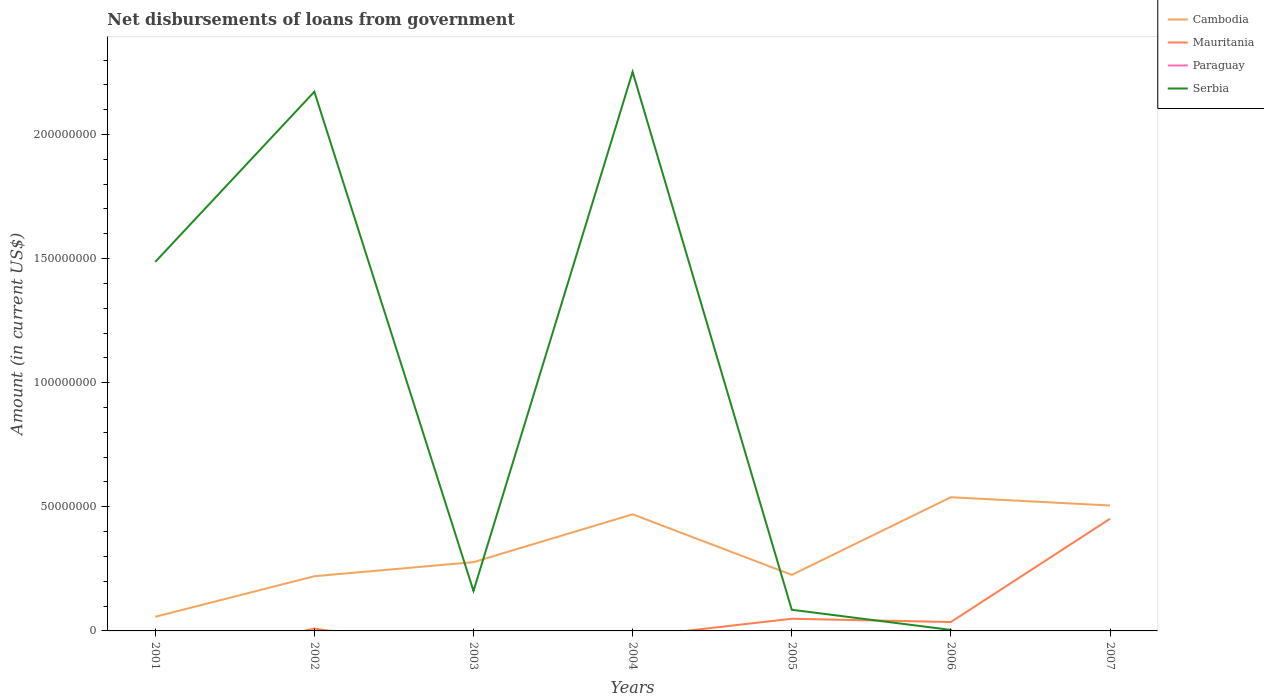Does the line corresponding to Mauritania intersect with the line corresponding to Serbia?
Your answer should be compact. Yes. Across all years, what is the maximum amount of loan disbursed from government in Serbia?
Keep it short and to the point. 0. What is the total amount of loan disbursed from government in Cambodia in the graph?
Make the answer very short. -5.67e+06. What is the difference between the highest and the second highest amount of loan disbursed from government in Cambodia?
Your answer should be very brief. 4.82e+07. How many lines are there?
Ensure brevity in your answer.  3. Are the values on the major ticks of Y-axis written in scientific E-notation?
Offer a very short reply. No. What is the title of the graph?
Provide a succinct answer. Net disbursements of loans from government. What is the label or title of the X-axis?
Offer a very short reply. Years. What is the Amount (in current US$) in Cambodia in 2001?
Your answer should be very brief. 5.69e+06. What is the Amount (in current US$) in Paraguay in 2001?
Provide a succinct answer. 0. What is the Amount (in current US$) in Serbia in 2001?
Your response must be concise. 1.49e+08. What is the Amount (in current US$) in Cambodia in 2002?
Your response must be concise. 2.20e+07. What is the Amount (in current US$) in Mauritania in 2002?
Your response must be concise. 9.69e+05. What is the Amount (in current US$) in Serbia in 2002?
Offer a terse response. 2.17e+08. What is the Amount (in current US$) in Cambodia in 2003?
Your response must be concise. 2.77e+07. What is the Amount (in current US$) of Paraguay in 2003?
Offer a very short reply. 0. What is the Amount (in current US$) of Serbia in 2003?
Offer a terse response. 1.61e+07. What is the Amount (in current US$) of Cambodia in 2004?
Keep it short and to the point. 4.70e+07. What is the Amount (in current US$) of Mauritania in 2004?
Offer a terse response. 0. What is the Amount (in current US$) in Serbia in 2004?
Offer a terse response. 2.25e+08. What is the Amount (in current US$) in Cambodia in 2005?
Your answer should be very brief. 2.26e+07. What is the Amount (in current US$) of Mauritania in 2005?
Give a very brief answer. 4.90e+06. What is the Amount (in current US$) of Serbia in 2005?
Provide a short and direct response. 8.52e+06. What is the Amount (in current US$) in Cambodia in 2006?
Offer a very short reply. 5.39e+07. What is the Amount (in current US$) of Mauritania in 2006?
Ensure brevity in your answer.  3.58e+06. What is the Amount (in current US$) of Cambodia in 2007?
Provide a short and direct response. 5.05e+07. What is the Amount (in current US$) of Mauritania in 2007?
Keep it short and to the point. 4.52e+07. What is the Amount (in current US$) in Serbia in 2007?
Your answer should be very brief. 0. Across all years, what is the maximum Amount (in current US$) of Cambodia?
Ensure brevity in your answer.  5.39e+07. Across all years, what is the maximum Amount (in current US$) in Mauritania?
Offer a terse response. 4.52e+07. Across all years, what is the maximum Amount (in current US$) in Serbia?
Ensure brevity in your answer.  2.25e+08. Across all years, what is the minimum Amount (in current US$) of Cambodia?
Provide a succinct answer. 5.69e+06. Across all years, what is the minimum Amount (in current US$) of Serbia?
Your response must be concise. 0. What is the total Amount (in current US$) in Cambodia in the graph?
Ensure brevity in your answer.  2.29e+08. What is the total Amount (in current US$) in Mauritania in the graph?
Keep it short and to the point. 5.46e+07. What is the total Amount (in current US$) in Serbia in the graph?
Your answer should be very brief. 6.16e+08. What is the difference between the Amount (in current US$) of Cambodia in 2001 and that in 2002?
Your answer should be compact. -1.63e+07. What is the difference between the Amount (in current US$) in Serbia in 2001 and that in 2002?
Ensure brevity in your answer.  -6.86e+07. What is the difference between the Amount (in current US$) of Cambodia in 2001 and that in 2003?
Give a very brief answer. -2.20e+07. What is the difference between the Amount (in current US$) in Serbia in 2001 and that in 2003?
Give a very brief answer. 1.33e+08. What is the difference between the Amount (in current US$) of Cambodia in 2001 and that in 2004?
Provide a succinct answer. -4.13e+07. What is the difference between the Amount (in current US$) in Serbia in 2001 and that in 2004?
Give a very brief answer. -7.66e+07. What is the difference between the Amount (in current US$) in Cambodia in 2001 and that in 2005?
Keep it short and to the point. -1.69e+07. What is the difference between the Amount (in current US$) of Serbia in 2001 and that in 2005?
Keep it short and to the point. 1.40e+08. What is the difference between the Amount (in current US$) of Cambodia in 2001 and that in 2006?
Ensure brevity in your answer.  -4.82e+07. What is the difference between the Amount (in current US$) of Serbia in 2001 and that in 2006?
Provide a short and direct response. 1.48e+08. What is the difference between the Amount (in current US$) in Cambodia in 2001 and that in 2007?
Keep it short and to the point. -4.48e+07. What is the difference between the Amount (in current US$) in Cambodia in 2002 and that in 2003?
Provide a short and direct response. -5.67e+06. What is the difference between the Amount (in current US$) in Serbia in 2002 and that in 2003?
Give a very brief answer. 2.01e+08. What is the difference between the Amount (in current US$) in Cambodia in 2002 and that in 2004?
Your response must be concise. -2.49e+07. What is the difference between the Amount (in current US$) in Serbia in 2002 and that in 2004?
Provide a succinct answer. -7.99e+06. What is the difference between the Amount (in current US$) of Cambodia in 2002 and that in 2005?
Your answer should be compact. -5.41e+05. What is the difference between the Amount (in current US$) in Mauritania in 2002 and that in 2005?
Keep it short and to the point. -3.93e+06. What is the difference between the Amount (in current US$) of Serbia in 2002 and that in 2005?
Your answer should be very brief. 2.09e+08. What is the difference between the Amount (in current US$) of Cambodia in 2002 and that in 2006?
Offer a terse response. -3.18e+07. What is the difference between the Amount (in current US$) in Mauritania in 2002 and that in 2006?
Offer a very short reply. -2.61e+06. What is the difference between the Amount (in current US$) of Serbia in 2002 and that in 2006?
Offer a terse response. 2.17e+08. What is the difference between the Amount (in current US$) in Cambodia in 2002 and that in 2007?
Make the answer very short. -2.85e+07. What is the difference between the Amount (in current US$) of Mauritania in 2002 and that in 2007?
Give a very brief answer. -4.42e+07. What is the difference between the Amount (in current US$) of Cambodia in 2003 and that in 2004?
Provide a short and direct response. -1.93e+07. What is the difference between the Amount (in current US$) of Serbia in 2003 and that in 2004?
Your response must be concise. -2.09e+08. What is the difference between the Amount (in current US$) in Cambodia in 2003 and that in 2005?
Your response must be concise. 5.13e+06. What is the difference between the Amount (in current US$) of Serbia in 2003 and that in 2005?
Keep it short and to the point. 7.58e+06. What is the difference between the Amount (in current US$) of Cambodia in 2003 and that in 2006?
Give a very brief answer. -2.62e+07. What is the difference between the Amount (in current US$) in Serbia in 2003 and that in 2006?
Your answer should be compact. 1.57e+07. What is the difference between the Amount (in current US$) of Cambodia in 2003 and that in 2007?
Your answer should be very brief. -2.28e+07. What is the difference between the Amount (in current US$) in Cambodia in 2004 and that in 2005?
Ensure brevity in your answer.  2.44e+07. What is the difference between the Amount (in current US$) of Serbia in 2004 and that in 2005?
Give a very brief answer. 2.17e+08. What is the difference between the Amount (in current US$) in Cambodia in 2004 and that in 2006?
Give a very brief answer. -6.88e+06. What is the difference between the Amount (in current US$) of Serbia in 2004 and that in 2006?
Make the answer very short. 2.25e+08. What is the difference between the Amount (in current US$) in Cambodia in 2004 and that in 2007?
Provide a succinct answer. -3.54e+06. What is the difference between the Amount (in current US$) in Cambodia in 2005 and that in 2006?
Keep it short and to the point. -3.13e+07. What is the difference between the Amount (in current US$) of Mauritania in 2005 and that in 2006?
Offer a very short reply. 1.32e+06. What is the difference between the Amount (in current US$) in Serbia in 2005 and that in 2006?
Offer a very short reply. 8.12e+06. What is the difference between the Amount (in current US$) in Cambodia in 2005 and that in 2007?
Provide a succinct answer. -2.79e+07. What is the difference between the Amount (in current US$) in Mauritania in 2005 and that in 2007?
Your response must be concise. -4.03e+07. What is the difference between the Amount (in current US$) in Cambodia in 2006 and that in 2007?
Keep it short and to the point. 3.34e+06. What is the difference between the Amount (in current US$) of Mauritania in 2006 and that in 2007?
Offer a terse response. -4.16e+07. What is the difference between the Amount (in current US$) of Cambodia in 2001 and the Amount (in current US$) of Mauritania in 2002?
Offer a terse response. 4.72e+06. What is the difference between the Amount (in current US$) in Cambodia in 2001 and the Amount (in current US$) in Serbia in 2002?
Keep it short and to the point. -2.12e+08. What is the difference between the Amount (in current US$) of Cambodia in 2001 and the Amount (in current US$) of Serbia in 2003?
Your response must be concise. -1.04e+07. What is the difference between the Amount (in current US$) of Cambodia in 2001 and the Amount (in current US$) of Serbia in 2004?
Keep it short and to the point. -2.20e+08. What is the difference between the Amount (in current US$) in Cambodia in 2001 and the Amount (in current US$) in Mauritania in 2005?
Ensure brevity in your answer.  7.90e+05. What is the difference between the Amount (in current US$) in Cambodia in 2001 and the Amount (in current US$) in Serbia in 2005?
Give a very brief answer. -2.84e+06. What is the difference between the Amount (in current US$) of Cambodia in 2001 and the Amount (in current US$) of Mauritania in 2006?
Give a very brief answer. 2.11e+06. What is the difference between the Amount (in current US$) of Cambodia in 2001 and the Amount (in current US$) of Serbia in 2006?
Your answer should be compact. 5.29e+06. What is the difference between the Amount (in current US$) of Cambodia in 2001 and the Amount (in current US$) of Mauritania in 2007?
Give a very brief answer. -3.95e+07. What is the difference between the Amount (in current US$) in Cambodia in 2002 and the Amount (in current US$) in Serbia in 2003?
Keep it short and to the point. 5.93e+06. What is the difference between the Amount (in current US$) of Mauritania in 2002 and the Amount (in current US$) of Serbia in 2003?
Make the answer very short. -1.51e+07. What is the difference between the Amount (in current US$) of Cambodia in 2002 and the Amount (in current US$) of Serbia in 2004?
Your answer should be very brief. -2.03e+08. What is the difference between the Amount (in current US$) in Mauritania in 2002 and the Amount (in current US$) in Serbia in 2004?
Your answer should be compact. -2.24e+08. What is the difference between the Amount (in current US$) of Cambodia in 2002 and the Amount (in current US$) of Mauritania in 2005?
Keep it short and to the point. 1.71e+07. What is the difference between the Amount (in current US$) of Cambodia in 2002 and the Amount (in current US$) of Serbia in 2005?
Your response must be concise. 1.35e+07. What is the difference between the Amount (in current US$) in Mauritania in 2002 and the Amount (in current US$) in Serbia in 2005?
Provide a succinct answer. -7.56e+06. What is the difference between the Amount (in current US$) in Cambodia in 2002 and the Amount (in current US$) in Mauritania in 2006?
Your answer should be very brief. 1.85e+07. What is the difference between the Amount (in current US$) in Cambodia in 2002 and the Amount (in current US$) in Serbia in 2006?
Ensure brevity in your answer.  2.16e+07. What is the difference between the Amount (in current US$) in Mauritania in 2002 and the Amount (in current US$) in Serbia in 2006?
Keep it short and to the point. 5.69e+05. What is the difference between the Amount (in current US$) in Cambodia in 2002 and the Amount (in current US$) in Mauritania in 2007?
Make the answer very short. -2.31e+07. What is the difference between the Amount (in current US$) of Cambodia in 2003 and the Amount (in current US$) of Serbia in 2004?
Provide a succinct answer. -1.98e+08. What is the difference between the Amount (in current US$) of Cambodia in 2003 and the Amount (in current US$) of Mauritania in 2005?
Ensure brevity in your answer.  2.28e+07. What is the difference between the Amount (in current US$) of Cambodia in 2003 and the Amount (in current US$) of Serbia in 2005?
Your response must be concise. 1.92e+07. What is the difference between the Amount (in current US$) in Cambodia in 2003 and the Amount (in current US$) in Mauritania in 2006?
Offer a terse response. 2.41e+07. What is the difference between the Amount (in current US$) of Cambodia in 2003 and the Amount (in current US$) of Serbia in 2006?
Make the answer very short. 2.73e+07. What is the difference between the Amount (in current US$) of Cambodia in 2003 and the Amount (in current US$) of Mauritania in 2007?
Make the answer very short. -1.75e+07. What is the difference between the Amount (in current US$) of Cambodia in 2004 and the Amount (in current US$) of Mauritania in 2005?
Ensure brevity in your answer.  4.21e+07. What is the difference between the Amount (in current US$) in Cambodia in 2004 and the Amount (in current US$) in Serbia in 2005?
Give a very brief answer. 3.85e+07. What is the difference between the Amount (in current US$) of Cambodia in 2004 and the Amount (in current US$) of Mauritania in 2006?
Keep it short and to the point. 4.34e+07. What is the difference between the Amount (in current US$) in Cambodia in 2004 and the Amount (in current US$) in Serbia in 2006?
Your answer should be compact. 4.66e+07. What is the difference between the Amount (in current US$) of Cambodia in 2004 and the Amount (in current US$) of Mauritania in 2007?
Offer a terse response. 1.80e+06. What is the difference between the Amount (in current US$) in Cambodia in 2005 and the Amount (in current US$) in Mauritania in 2006?
Ensure brevity in your answer.  1.90e+07. What is the difference between the Amount (in current US$) in Cambodia in 2005 and the Amount (in current US$) in Serbia in 2006?
Ensure brevity in your answer.  2.22e+07. What is the difference between the Amount (in current US$) in Mauritania in 2005 and the Amount (in current US$) in Serbia in 2006?
Ensure brevity in your answer.  4.50e+06. What is the difference between the Amount (in current US$) of Cambodia in 2005 and the Amount (in current US$) of Mauritania in 2007?
Ensure brevity in your answer.  -2.26e+07. What is the difference between the Amount (in current US$) in Cambodia in 2006 and the Amount (in current US$) in Mauritania in 2007?
Offer a terse response. 8.69e+06. What is the average Amount (in current US$) of Cambodia per year?
Offer a very short reply. 3.28e+07. What is the average Amount (in current US$) of Mauritania per year?
Keep it short and to the point. 7.80e+06. What is the average Amount (in current US$) in Paraguay per year?
Your response must be concise. 0. What is the average Amount (in current US$) of Serbia per year?
Keep it short and to the point. 8.80e+07. In the year 2001, what is the difference between the Amount (in current US$) of Cambodia and Amount (in current US$) of Serbia?
Provide a short and direct response. -1.43e+08. In the year 2002, what is the difference between the Amount (in current US$) in Cambodia and Amount (in current US$) in Mauritania?
Your response must be concise. 2.11e+07. In the year 2002, what is the difference between the Amount (in current US$) of Cambodia and Amount (in current US$) of Serbia?
Offer a very short reply. -1.95e+08. In the year 2002, what is the difference between the Amount (in current US$) of Mauritania and Amount (in current US$) of Serbia?
Give a very brief answer. -2.16e+08. In the year 2003, what is the difference between the Amount (in current US$) in Cambodia and Amount (in current US$) in Serbia?
Give a very brief answer. 1.16e+07. In the year 2004, what is the difference between the Amount (in current US$) of Cambodia and Amount (in current US$) of Serbia?
Give a very brief answer. -1.78e+08. In the year 2005, what is the difference between the Amount (in current US$) of Cambodia and Amount (in current US$) of Mauritania?
Give a very brief answer. 1.77e+07. In the year 2005, what is the difference between the Amount (in current US$) in Cambodia and Amount (in current US$) in Serbia?
Your response must be concise. 1.41e+07. In the year 2005, what is the difference between the Amount (in current US$) in Mauritania and Amount (in current US$) in Serbia?
Make the answer very short. -3.63e+06. In the year 2006, what is the difference between the Amount (in current US$) in Cambodia and Amount (in current US$) in Mauritania?
Your answer should be very brief. 5.03e+07. In the year 2006, what is the difference between the Amount (in current US$) in Cambodia and Amount (in current US$) in Serbia?
Give a very brief answer. 5.35e+07. In the year 2006, what is the difference between the Amount (in current US$) in Mauritania and Amount (in current US$) in Serbia?
Your response must be concise. 3.18e+06. In the year 2007, what is the difference between the Amount (in current US$) of Cambodia and Amount (in current US$) of Mauritania?
Offer a terse response. 5.34e+06. What is the ratio of the Amount (in current US$) in Cambodia in 2001 to that in 2002?
Offer a very short reply. 0.26. What is the ratio of the Amount (in current US$) in Serbia in 2001 to that in 2002?
Ensure brevity in your answer.  0.68. What is the ratio of the Amount (in current US$) in Cambodia in 2001 to that in 2003?
Provide a succinct answer. 0.21. What is the ratio of the Amount (in current US$) in Serbia in 2001 to that in 2003?
Provide a short and direct response. 9.23. What is the ratio of the Amount (in current US$) of Cambodia in 2001 to that in 2004?
Make the answer very short. 0.12. What is the ratio of the Amount (in current US$) of Serbia in 2001 to that in 2004?
Your answer should be compact. 0.66. What is the ratio of the Amount (in current US$) of Cambodia in 2001 to that in 2005?
Give a very brief answer. 0.25. What is the ratio of the Amount (in current US$) in Serbia in 2001 to that in 2005?
Your response must be concise. 17.44. What is the ratio of the Amount (in current US$) of Cambodia in 2001 to that in 2006?
Offer a terse response. 0.11. What is the ratio of the Amount (in current US$) in Serbia in 2001 to that in 2006?
Ensure brevity in your answer.  371.64. What is the ratio of the Amount (in current US$) in Cambodia in 2001 to that in 2007?
Your answer should be compact. 0.11. What is the ratio of the Amount (in current US$) of Cambodia in 2002 to that in 2003?
Make the answer very short. 0.8. What is the ratio of the Amount (in current US$) in Serbia in 2002 to that in 2003?
Your answer should be compact. 13.49. What is the ratio of the Amount (in current US$) in Cambodia in 2002 to that in 2004?
Keep it short and to the point. 0.47. What is the ratio of the Amount (in current US$) in Serbia in 2002 to that in 2004?
Provide a short and direct response. 0.96. What is the ratio of the Amount (in current US$) of Cambodia in 2002 to that in 2005?
Ensure brevity in your answer.  0.98. What is the ratio of the Amount (in current US$) of Mauritania in 2002 to that in 2005?
Your response must be concise. 0.2. What is the ratio of the Amount (in current US$) of Serbia in 2002 to that in 2005?
Ensure brevity in your answer.  25.48. What is the ratio of the Amount (in current US$) of Cambodia in 2002 to that in 2006?
Provide a succinct answer. 0.41. What is the ratio of the Amount (in current US$) of Mauritania in 2002 to that in 2006?
Offer a terse response. 0.27. What is the ratio of the Amount (in current US$) of Serbia in 2002 to that in 2006?
Give a very brief answer. 543.06. What is the ratio of the Amount (in current US$) in Cambodia in 2002 to that in 2007?
Offer a terse response. 0.44. What is the ratio of the Amount (in current US$) in Mauritania in 2002 to that in 2007?
Offer a very short reply. 0.02. What is the ratio of the Amount (in current US$) of Cambodia in 2003 to that in 2004?
Your answer should be compact. 0.59. What is the ratio of the Amount (in current US$) of Serbia in 2003 to that in 2004?
Provide a short and direct response. 0.07. What is the ratio of the Amount (in current US$) in Cambodia in 2003 to that in 2005?
Your answer should be compact. 1.23. What is the ratio of the Amount (in current US$) in Serbia in 2003 to that in 2005?
Keep it short and to the point. 1.89. What is the ratio of the Amount (in current US$) of Cambodia in 2003 to that in 2006?
Your answer should be very brief. 0.51. What is the ratio of the Amount (in current US$) of Serbia in 2003 to that in 2006?
Your response must be concise. 40.27. What is the ratio of the Amount (in current US$) of Cambodia in 2003 to that in 2007?
Your answer should be compact. 0.55. What is the ratio of the Amount (in current US$) of Cambodia in 2004 to that in 2005?
Your answer should be compact. 2.08. What is the ratio of the Amount (in current US$) of Serbia in 2004 to that in 2005?
Offer a terse response. 26.42. What is the ratio of the Amount (in current US$) of Cambodia in 2004 to that in 2006?
Keep it short and to the point. 0.87. What is the ratio of the Amount (in current US$) in Serbia in 2004 to that in 2006?
Keep it short and to the point. 563.04. What is the ratio of the Amount (in current US$) in Cambodia in 2004 to that in 2007?
Ensure brevity in your answer.  0.93. What is the ratio of the Amount (in current US$) of Cambodia in 2005 to that in 2006?
Offer a very short reply. 0.42. What is the ratio of the Amount (in current US$) of Mauritania in 2005 to that in 2006?
Provide a short and direct response. 1.37. What is the ratio of the Amount (in current US$) in Serbia in 2005 to that in 2006?
Keep it short and to the point. 21.31. What is the ratio of the Amount (in current US$) in Cambodia in 2005 to that in 2007?
Ensure brevity in your answer.  0.45. What is the ratio of the Amount (in current US$) in Mauritania in 2005 to that in 2007?
Give a very brief answer. 0.11. What is the ratio of the Amount (in current US$) in Cambodia in 2006 to that in 2007?
Provide a short and direct response. 1.07. What is the ratio of the Amount (in current US$) in Mauritania in 2006 to that in 2007?
Your answer should be very brief. 0.08. What is the difference between the highest and the second highest Amount (in current US$) in Cambodia?
Your response must be concise. 3.34e+06. What is the difference between the highest and the second highest Amount (in current US$) in Mauritania?
Your answer should be very brief. 4.03e+07. What is the difference between the highest and the second highest Amount (in current US$) in Serbia?
Offer a terse response. 7.99e+06. What is the difference between the highest and the lowest Amount (in current US$) in Cambodia?
Offer a terse response. 4.82e+07. What is the difference between the highest and the lowest Amount (in current US$) of Mauritania?
Ensure brevity in your answer.  4.52e+07. What is the difference between the highest and the lowest Amount (in current US$) of Serbia?
Ensure brevity in your answer.  2.25e+08. 